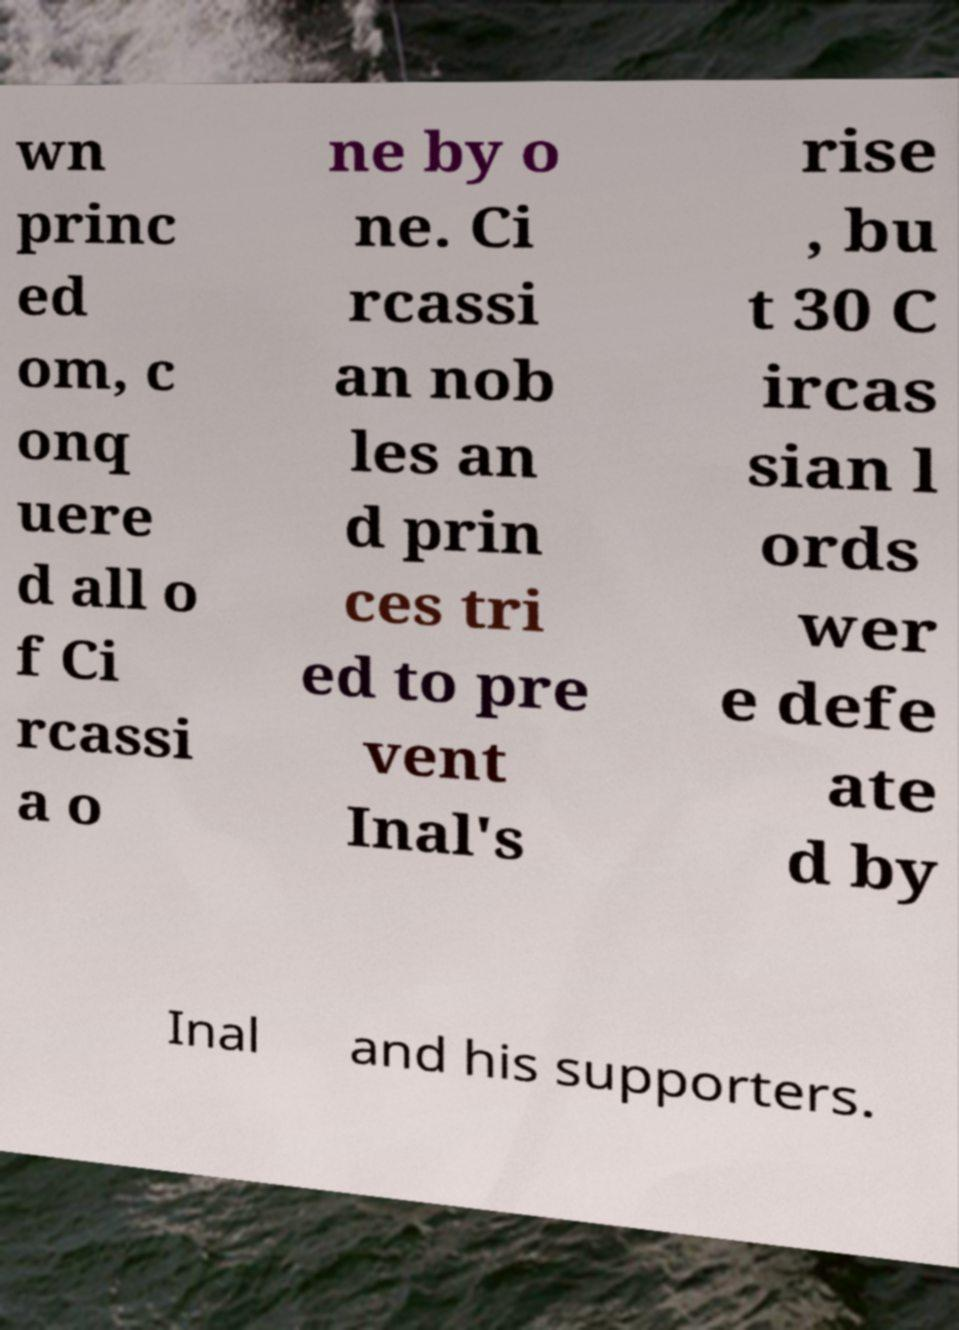Can you read and provide the text displayed in the image?This photo seems to have some interesting text. Can you extract and type it out for me? wn princ ed om, c onq uere d all o f Ci rcassi a o ne by o ne. Ci rcassi an nob les an d prin ces tri ed to pre vent Inal's rise , bu t 30 C ircas sian l ords wer e defe ate d by Inal and his supporters. 